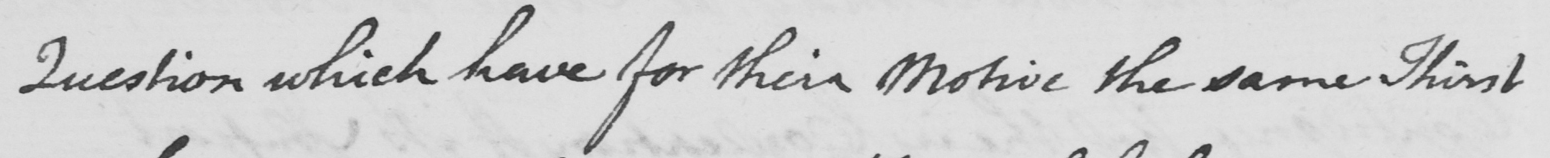What text is written in this handwritten line? Question which have for their motive the same Thirst 